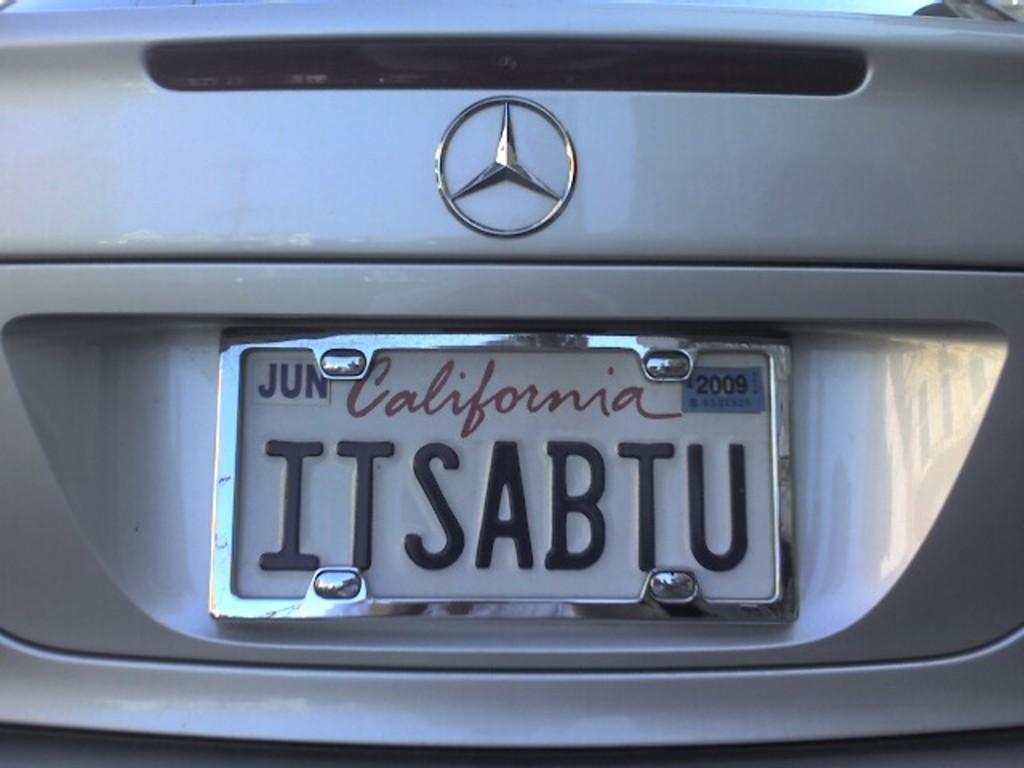What state is the plate from?
Make the answer very short. California. 